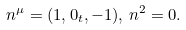<formula> <loc_0><loc_0><loc_500><loc_500>n ^ { \mu } = ( 1 , { 0 _ { t } } , - 1 ) , \, n ^ { 2 } = 0 .</formula> 